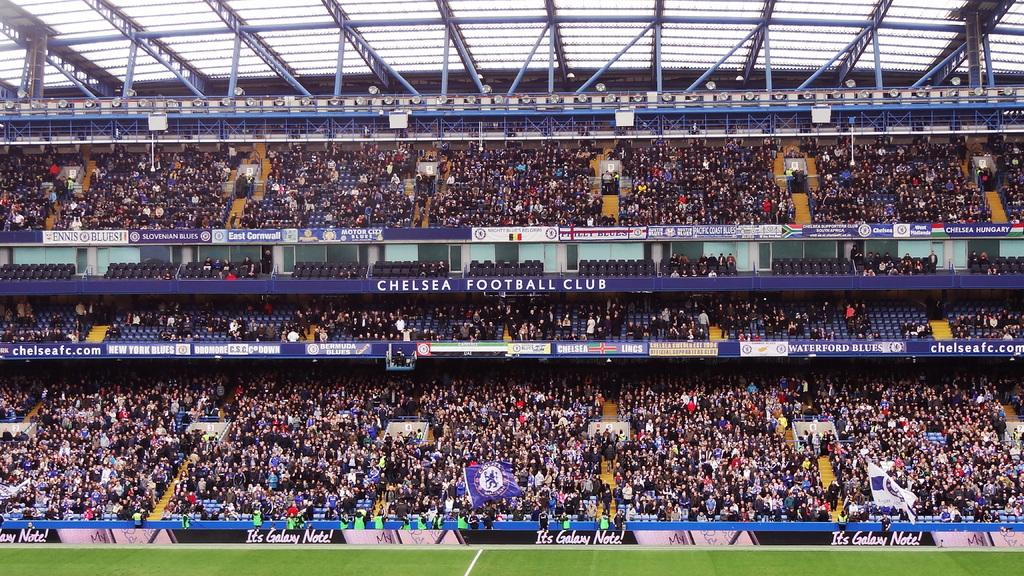<image>
Present a compact description of the photo's key features. crowded stadium at the chelsea football club sponsored by the galaxy note 